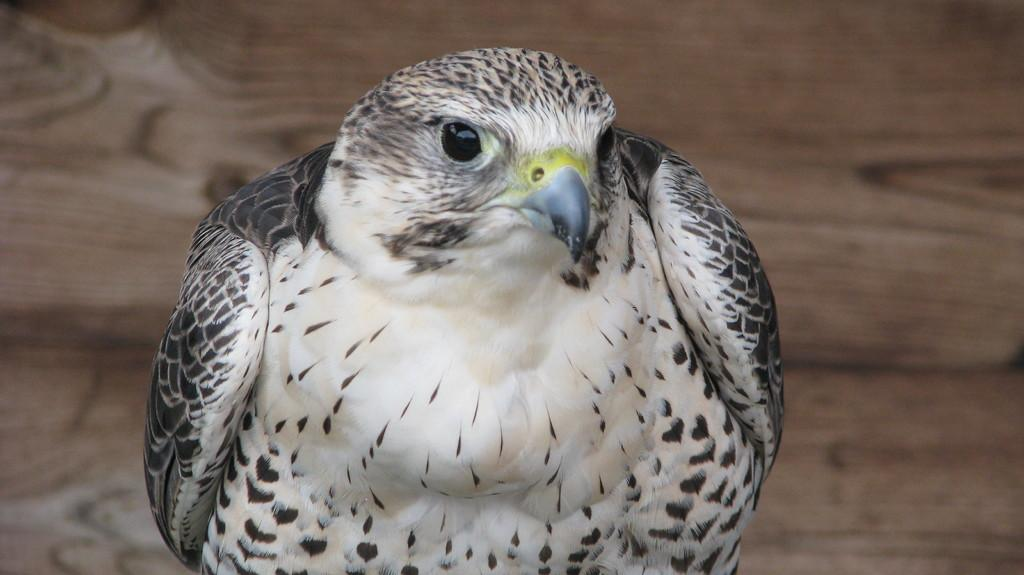What type of animal can be seen in the image? There is a bird in the image. Can you describe the bird's appearance? The bird has multiple colors, including white, black, gray, and yellow. What type of surface is visible in the image? There is a wooden surface in the image. What type of button can be seen on the bird's wing in the image? There is no button present on the bird's wing in the image. How many members of the bird's family are visible in the image? There is no indication of the bird's family in the image, as only one bird is visible. 